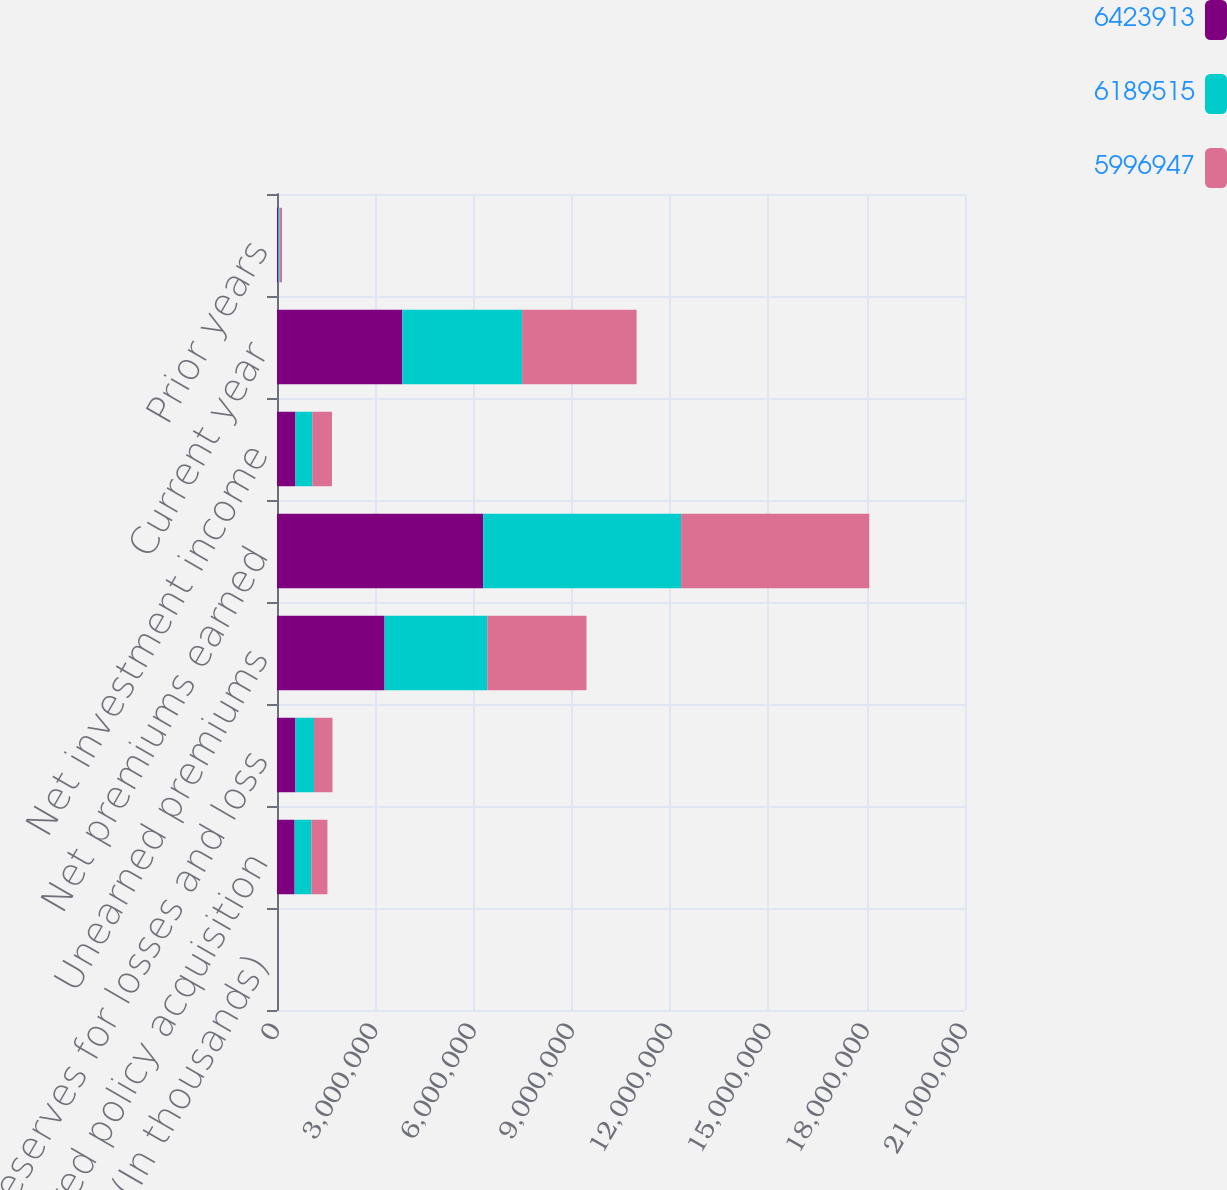<chart> <loc_0><loc_0><loc_500><loc_500><stacked_bar_chart><ecel><fcel>(In thousands)<fcel>Deferred policy acquisition<fcel>Reserves for losses and loss<fcel>Unearned premiums<fcel>Net premiums earned<fcel>Net investment income<fcel>Current year<fcel>Prior years<nl><fcel>6.42391e+06<fcel>2016<fcel>537890<fcel>564163<fcel>3.2833e+06<fcel>6.29335e+06<fcel>564163<fcel>3.82662e+06<fcel>29904<nl><fcel>6.18952e+06<fcel>2015<fcel>513128<fcel>564163<fcel>3.13713e+06<fcel>6.04061e+06<fcel>512645<fcel>3.65356e+06<fcel>46713<nl><fcel>5.99695e+06<fcel>2014<fcel>488525<fcel>564163<fcel>3.02673e+06<fcel>5.74442e+06<fcel>600885<fcel>3.49582e+06<fcel>75764<nl></chart> 